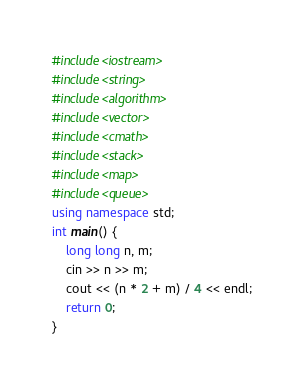<code> <loc_0><loc_0><loc_500><loc_500><_C++_>#include<iostream>
#include<string>
#include<algorithm>
#include<vector>
#include<cmath>
#include<stack>
#include<map>
#include<queue>
using namespace std;
int main() {
	long long n, m;
	cin >> n >> m;
	cout << (n * 2 + m) / 4 << endl;
	return 0;
}</code> 